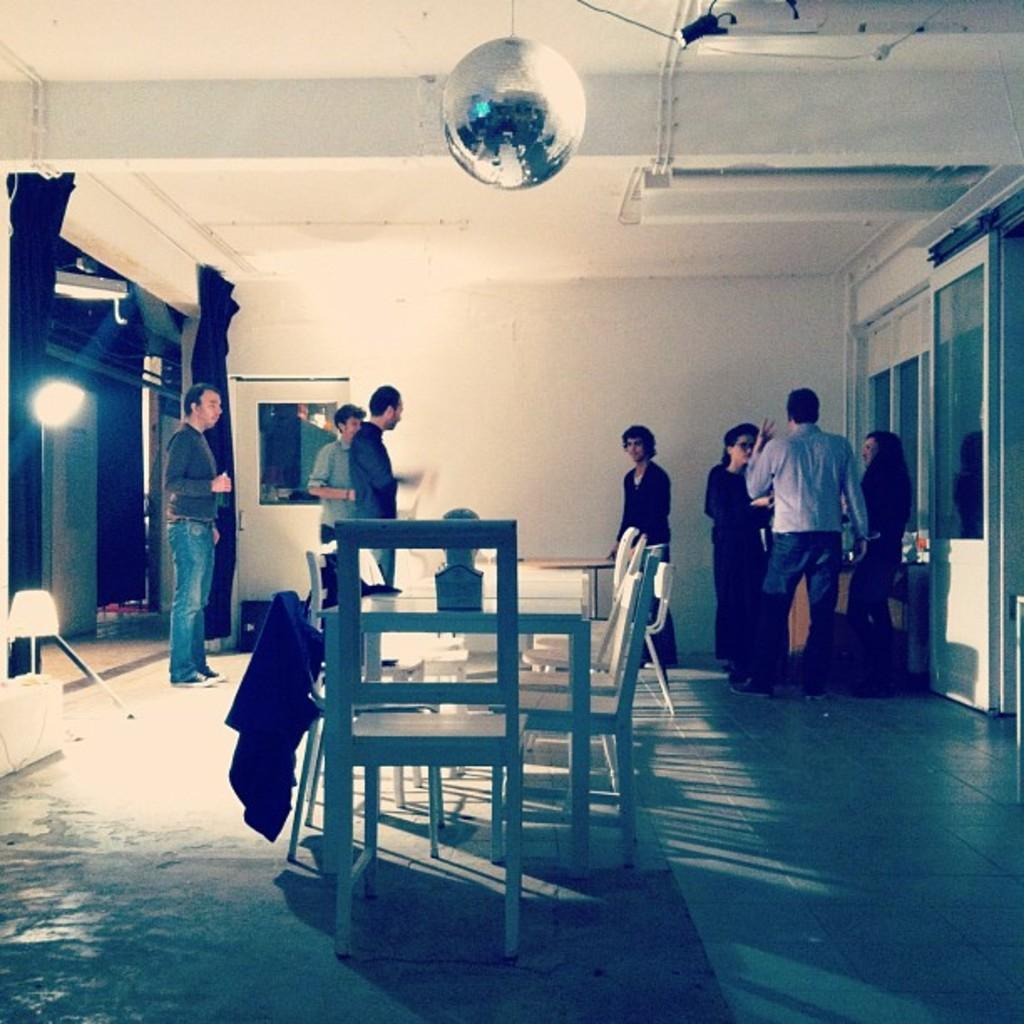How many people are in the image? There is a group of people in the image, but the exact number is not specified. What are some of the people in the image doing? Some people are standing, and some people are talking. What type of furniture is present in the image? There are tables and chairs in the image. What can be seen in the background of the image? There is a wall, curtains, a light, and doors in the background of the image. What type of feast is being celebrated in the image? There is no indication of a feast or celebration in the image. Can you tell me the date of the event from the calendar in the image? There is no calendar present in the image. 